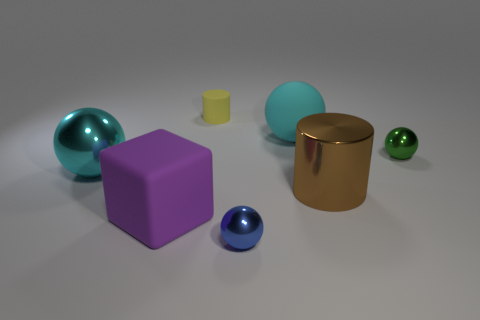Are there fewer big purple rubber cubes than big red shiny blocks? Yes, there is one big purple rubber cube, whereas there are no big red shiny blocks present at all. Thus, one cannot have fewer of something that does not exist in the image. 